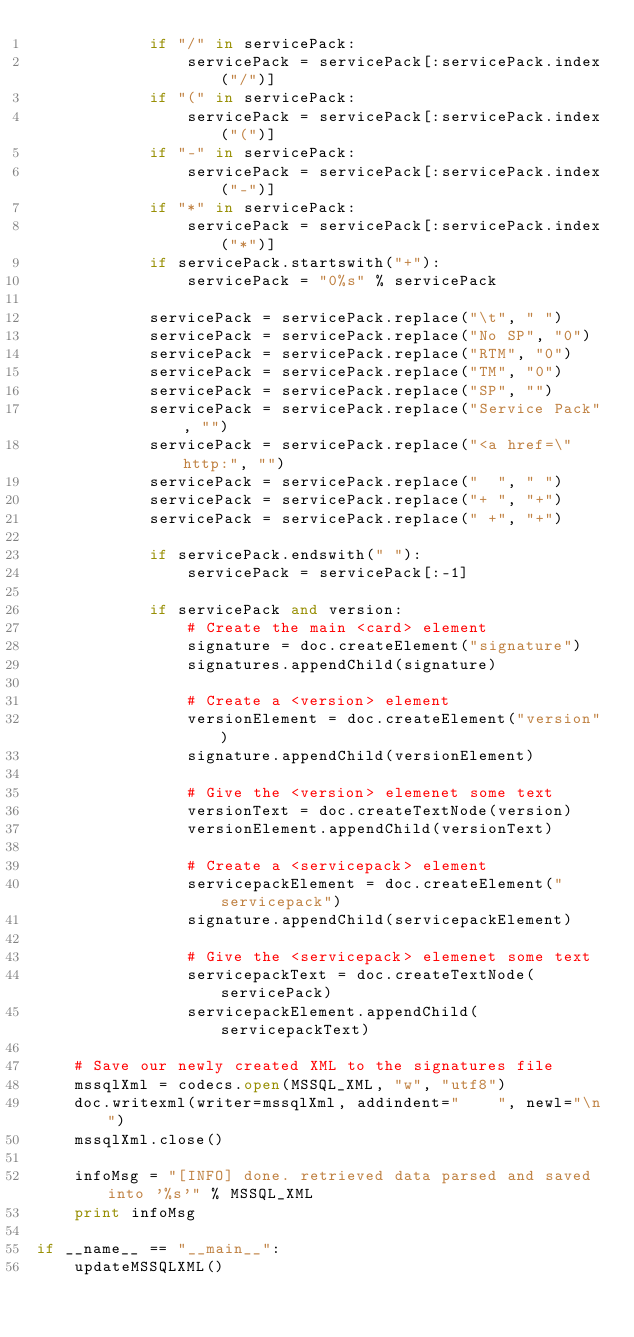<code> <loc_0><loc_0><loc_500><loc_500><_Python_>            if "/" in servicePack:
                servicePack = servicePack[:servicePack.index("/")]
            if "(" in servicePack:
                servicePack = servicePack[:servicePack.index("(")]
            if "-" in servicePack:
                servicePack = servicePack[:servicePack.index("-")]
            if "*" in servicePack:
                servicePack = servicePack[:servicePack.index("*")]
            if servicePack.startswith("+"):
                servicePack = "0%s" % servicePack

            servicePack = servicePack.replace("\t", " ")
            servicePack = servicePack.replace("No SP", "0")
            servicePack = servicePack.replace("RTM", "0")
            servicePack = servicePack.replace("TM", "0")
            servicePack = servicePack.replace("SP", "")
            servicePack = servicePack.replace("Service Pack", "")
            servicePack = servicePack.replace("<a href=\"http:", "")
            servicePack = servicePack.replace("  ", " ")
            servicePack = servicePack.replace("+ ", "+")
            servicePack = servicePack.replace(" +", "+")

            if servicePack.endswith(" "):
                servicePack = servicePack[:-1]

            if servicePack and version:
                # Create the main <card> element
                signature = doc.createElement("signature")
                signatures.appendChild(signature)

                # Create a <version> element
                versionElement = doc.createElement("version")
                signature.appendChild(versionElement)

                # Give the <version> elemenet some text
                versionText = doc.createTextNode(version)
                versionElement.appendChild(versionText)

                # Create a <servicepack> element
                servicepackElement = doc.createElement("servicepack")
                signature.appendChild(servicepackElement)

                # Give the <servicepack> elemenet some text
                servicepackText = doc.createTextNode(servicePack)
                servicepackElement.appendChild(servicepackText)

    # Save our newly created XML to the signatures file
    mssqlXml = codecs.open(MSSQL_XML, "w", "utf8")
    doc.writexml(writer=mssqlXml, addindent="    ", newl="\n")
    mssqlXml.close()

    infoMsg = "[INFO] done. retrieved data parsed and saved into '%s'" % MSSQL_XML
    print infoMsg

if __name__ == "__main__":
    updateMSSQLXML()
</code> 